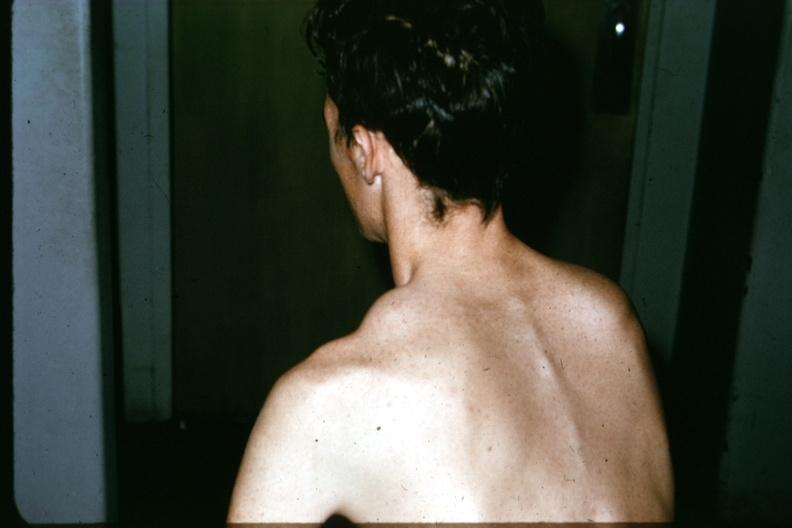s joints present?
Answer the question using a single word or phrase. Yes 